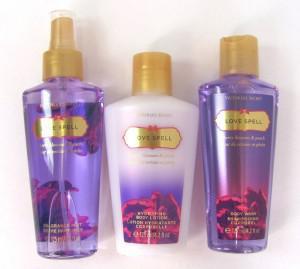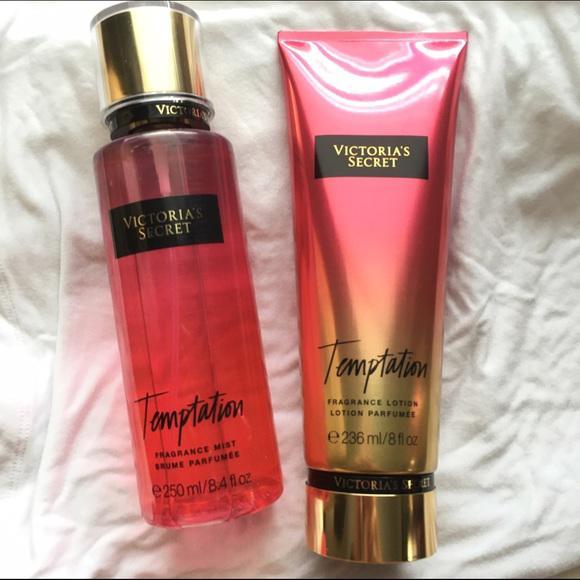The first image is the image on the left, the second image is the image on the right. Evaluate the accuracy of this statement regarding the images: "There are less than five containers in at least one of the images.". Is it true? Answer yes or no. Yes. The first image is the image on the left, the second image is the image on the right. Examine the images to the left and right. Is the description "The right image includes only products with shiny gold caps and includes at least one tube-type product designed to stand on its cap." accurate? Answer yes or no. Yes. 